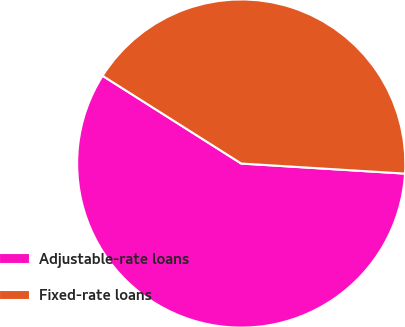<chart> <loc_0><loc_0><loc_500><loc_500><pie_chart><fcel>Adjustable-rate loans<fcel>Fixed-rate loans<nl><fcel>58.0%<fcel>42.0%<nl></chart> 